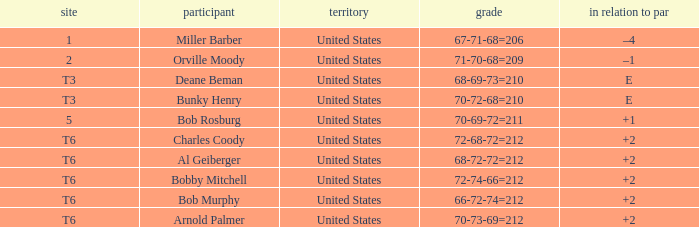Who is the player with a t6 place and a 72-68-72=212 score? Charles Coody. 